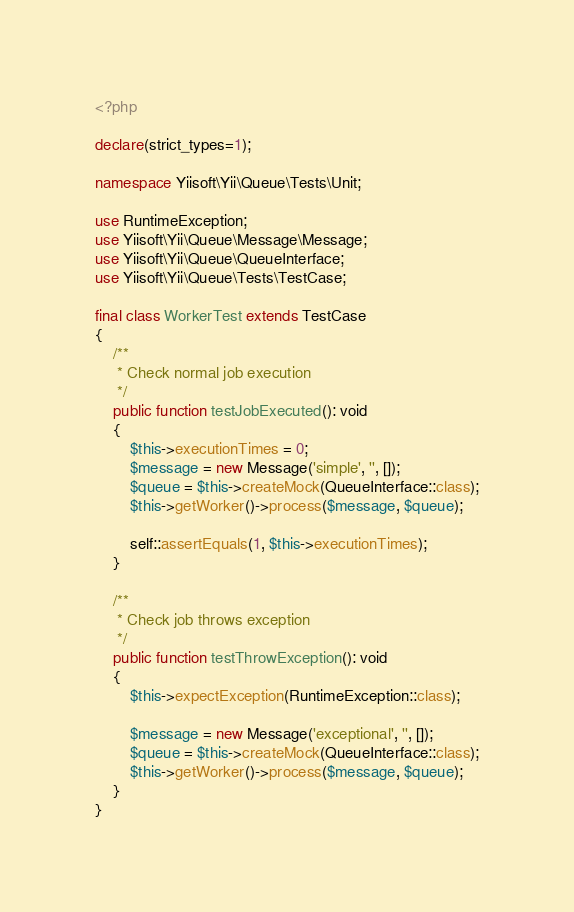<code> <loc_0><loc_0><loc_500><loc_500><_PHP_><?php

declare(strict_types=1);

namespace Yiisoft\Yii\Queue\Tests\Unit;

use RuntimeException;
use Yiisoft\Yii\Queue\Message\Message;
use Yiisoft\Yii\Queue\QueueInterface;
use Yiisoft\Yii\Queue\Tests\TestCase;

final class WorkerTest extends TestCase
{
    /**
     * Check normal job execution
     */
    public function testJobExecuted(): void
    {
        $this->executionTimes = 0;
        $message = new Message('simple', '', []);
        $queue = $this->createMock(QueueInterface::class);
        $this->getWorker()->process($message, $queue);

        self::assertEquals(1, $this->executionTimes);
    }

    /**
     * Check job throws exception
     */
    public function testThrowException(): void
    {
        $this->expectException(RuntimeException::class);

        $message = new Message('exceptional', '', []);
        $queue = $this->createMock(QueueInterface::class);
        $this->getWorker()->process($message, $queue);
    }
}
</code> 